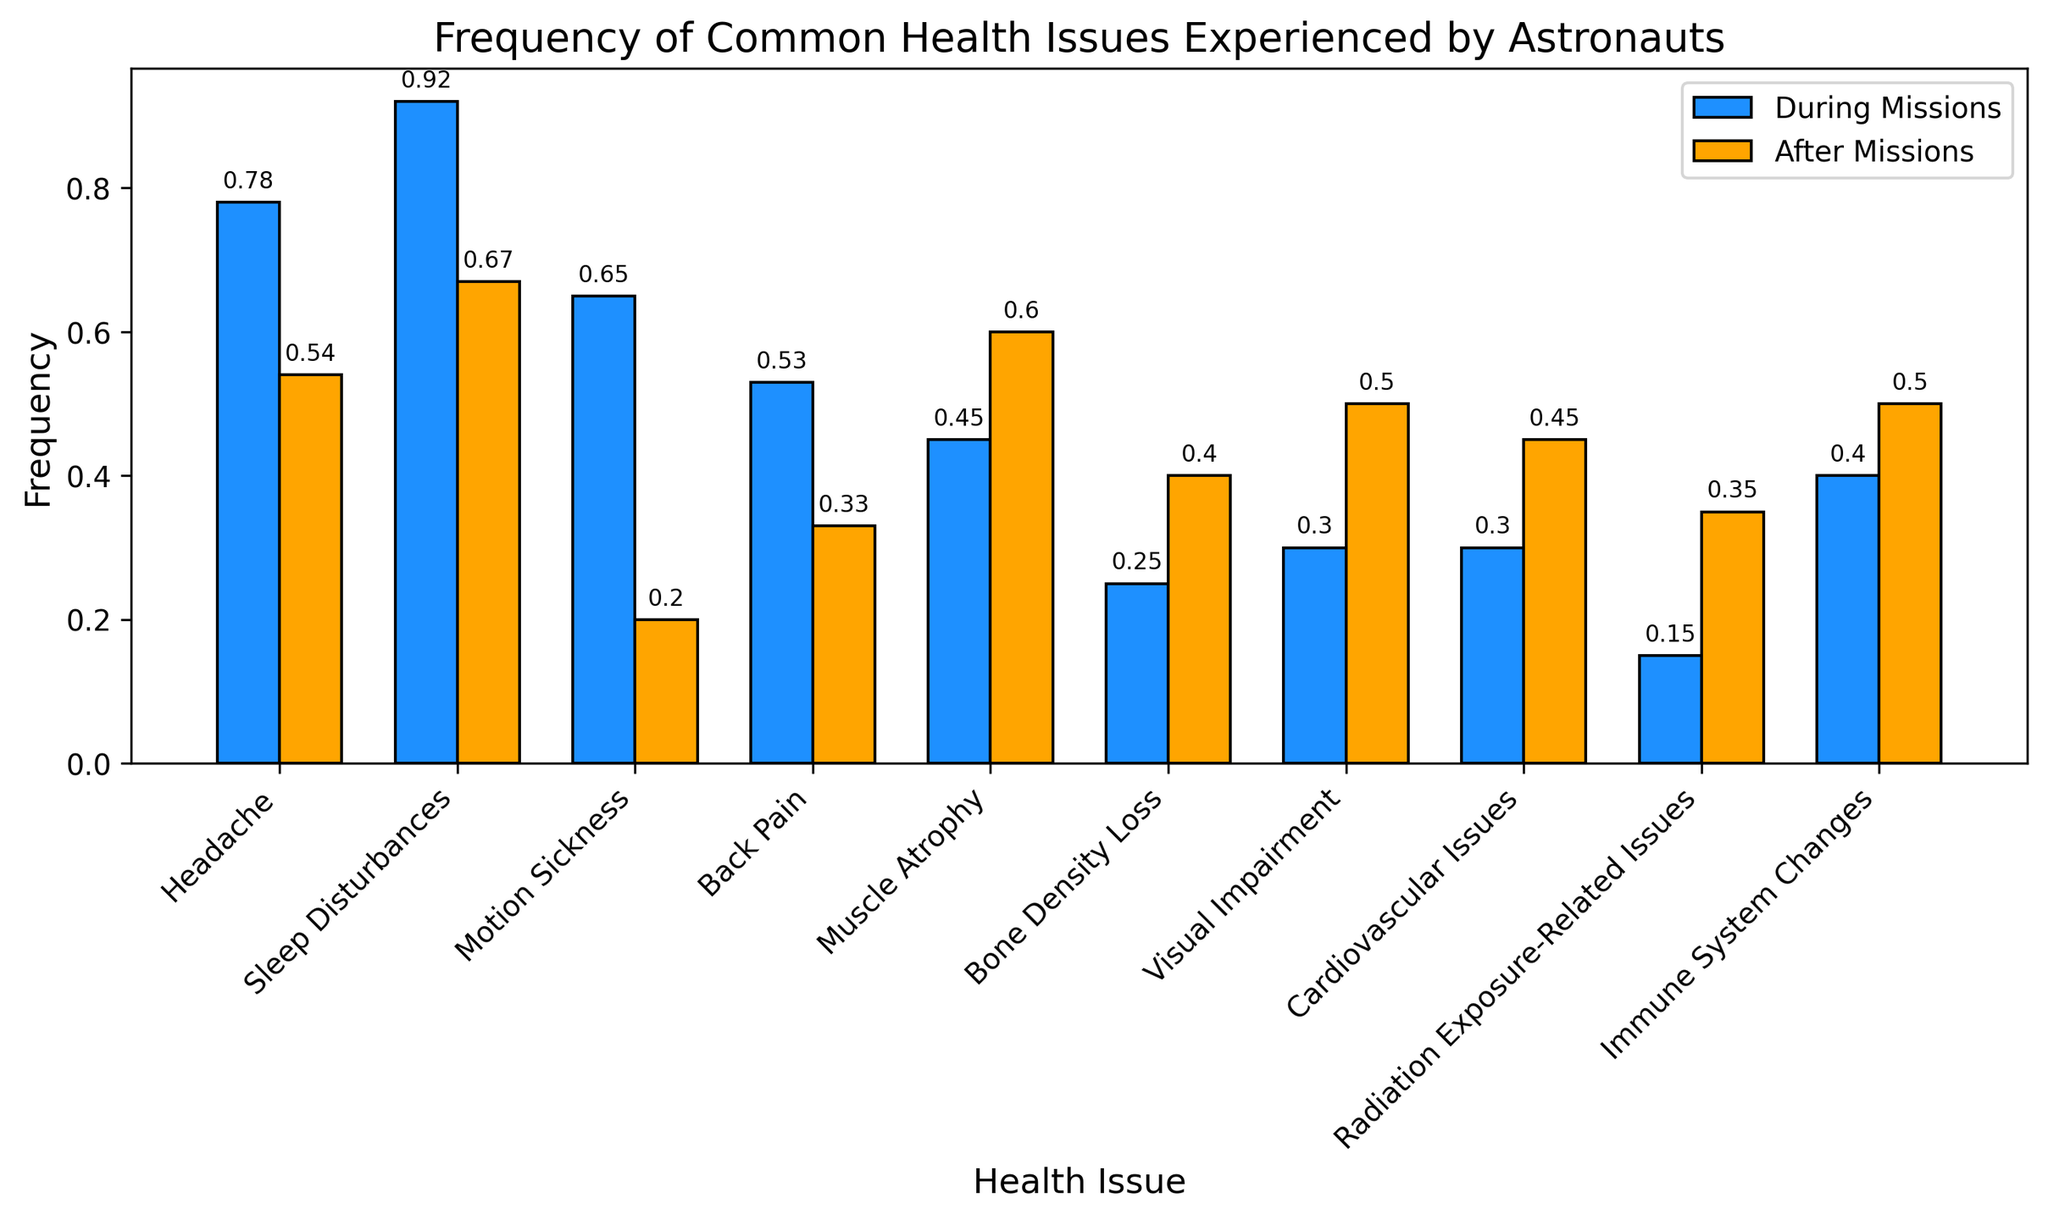Which health issue has the highest frequency during missions? The health issue with the highest bar in the "During Missions" section is Sleep Disturbances, as indicated by its bar being taller than the others.
Answer: Sleep Disturbances Which health issue shows a higher frequency after missions compared to during missions? To find this, compare the height of each pair of bars (During Missions and After Missions). Muscle Atrophy, Bone Density Loss, Visual Impairment, Cardiovascular Issues, and Radiation Exposure-Related Issues have taller bars "After Missions" than "During Missions".
Answer: Muscle Atrophy, Bone Density Loss, Visual Impairment, Cardiovascular Issues, Radiation Exposure-Related Issues What is the combined frequency of headaches during and after missions? Add the frequency of headaches during missions (0.78) to the frequency of headaches after missions (0.54): 0.78 + 0.54 = 1.32.
Answer: 1.32 Which two health issues have the same frequency during missions? Scan the bars for "During Missions" to identify equal heights. Visual Impairment and Cardiovascular Issues both have a frequency of 0.30 during missions.
Answer: Visual Impairment, Cardiovascular Issues By how much does the frequency of sleep disturbances decrease after missions? Subtract the frequency of sleep disturbances after missions (0.67) from the frequency during missions (0.92): 0.92 - 0.67 = 0.25.
Answer: 0.25 What is the average frequency of immune system changes during and after missions? Calculate the sum of the immune system changes frequencies (0.40 + 0.50) and divide by 2: (0.40 + 0.50) / 2 = 0.45.
Answer: 0.45 Which health issue has the smallest difference in frequency between during and after missions? Calculate the absolute difference for each health issue and find the smallest one. The difference for Bone Density Loss is smallest:
Answer: Bone Density Loss Which two health issues have a combined frequency of greater than 1.0 both during and after missions? Add the frequencies for each health issue pair for both periods. Sleep Disturbances (0.92 + 0.67 = 1.59) and Headache (0.78 + 0.54 = 1.32) exceed 1.0.
Answer: Sleep Disturbances, Headache What is the total frequency of muscle atrophy both during and after missions combined? Sum the frequency of muscle atrophy during (0.45) and after missions (0.60): 0.45 + 0.60 = 1.05.
Answer: 1.05 